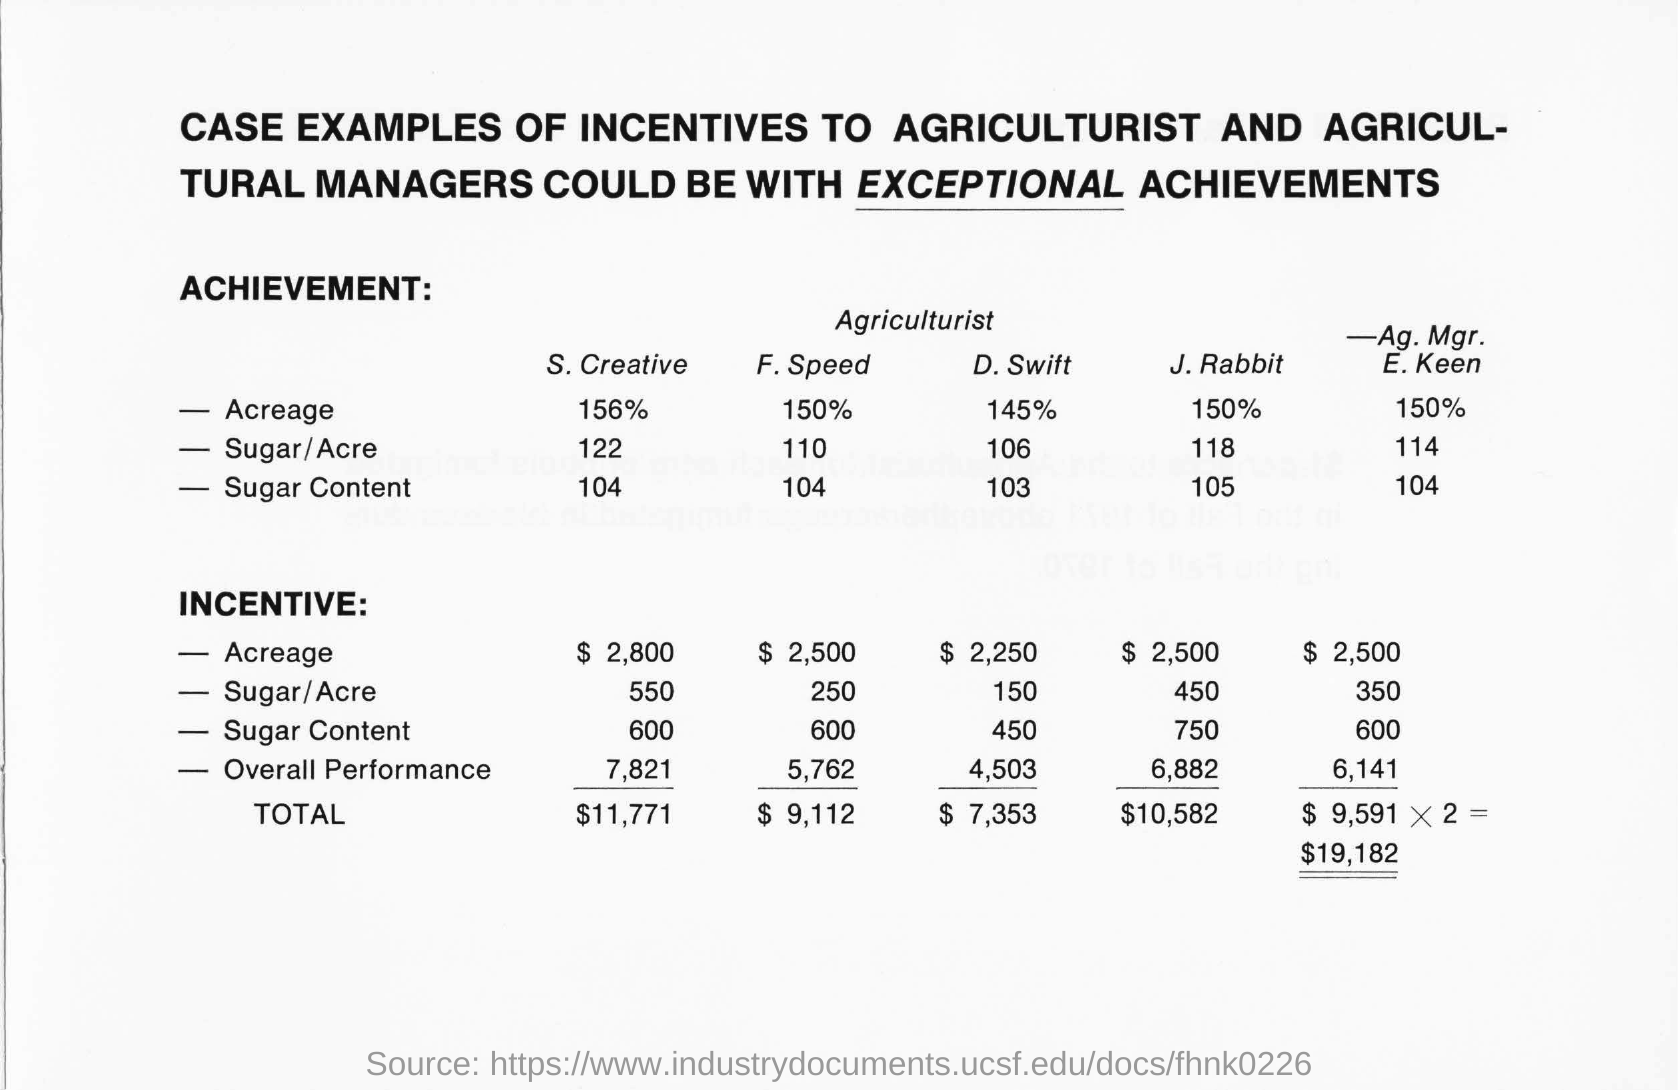What is underlined  in the top of the document ?
Make the answer very short. Exceptional. What is the percentage of F. Speed of Acreage ?
Provide a succinct answer. 150%. 